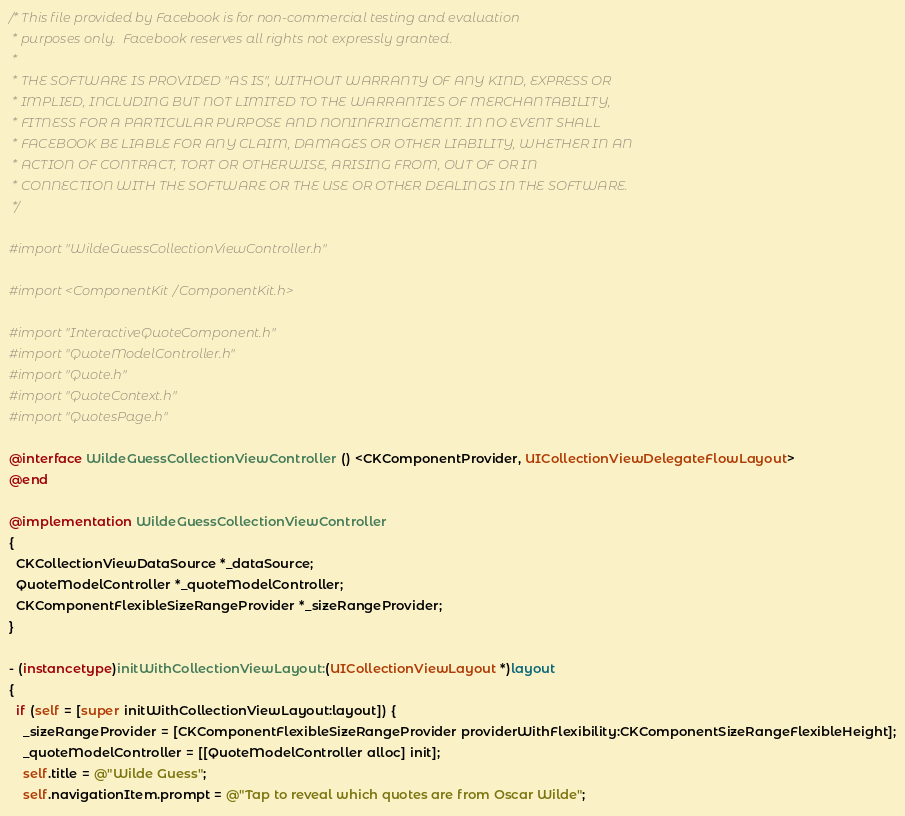<code> <loc_0><loc_0><loc_500><loc_500><_ObjectiveC_>/* This file provided by Facebook is for non-commercial testing and evaluation
 * purposes only.  Facebook reserves all rights not expressly granted.
 *
 * THE SOFTWARE IS PROVIDED "AS IS", WITHOUT WARRANTY OF ANY KIND, EXPRESS OR
 * IMPLIED, INCLUDING BUT NOT LIMITED TO THE WARRANTIES OF MERCHANTABILITY,
 * FITNESS FOR A PARTICULAR PURPOSE AND NONINFRINGEMENT. IN NO EVENT SHALL
 * FACEBOOK BE LIABLE FOR ANY CLAIM, DAMAGES OR OTHER LIABILITY, WHETHER IN AN
 * ACTION OF CONTRACT, TORT OR OTHERWISE, ARISING FROM, OUT OF OR IN
 * CONNECTION WITH THE SOFTWARE OR THE USE OR OTHER DEALINGS IN THE SOFTWARE.
 */

#import "WildeGuessCollectionViewController.h"

#import <ComponentKit/ComponentKit.h>

#import "InteractiveQuoteComponent.h"
#import "QuoteModelController.h"
#import "Quote.h"
#import "QuoteContext.h"
#import "QuotesPage.h"

@interface WildeGuessCollectionViewController () <CKComponentProvider, UICollectionViewDelegateFlowLayout>
@end

@implementation WildeGuessCollectionViewController
{
  CKCollectionViewDataSource *_dataSource;
  QuoteModelController *_quoteModelController;
  CKComponentFlexibleSizeRangeProvider *_sizeRangeProvider;
}

- (instancetype)initWithCollectionViewLayout:(UICollectionViewLayout *)layout
{
  if (self = [super initWithCollectionViewLayout:layout]) {
    _sizeRangeProvider = [CKComponentFlexibleSizeRangeProvider providerWithFlexibility:CKComponentSizeRangeFlexibleHeight];
    _quoteModelController = [[QuoteModelController alloc] init];
    self.title = @"Wilde Guess";
    self.navigationItem.prompt = @"Tap to reveal which quotes are from Oscar Wilde";</code> 